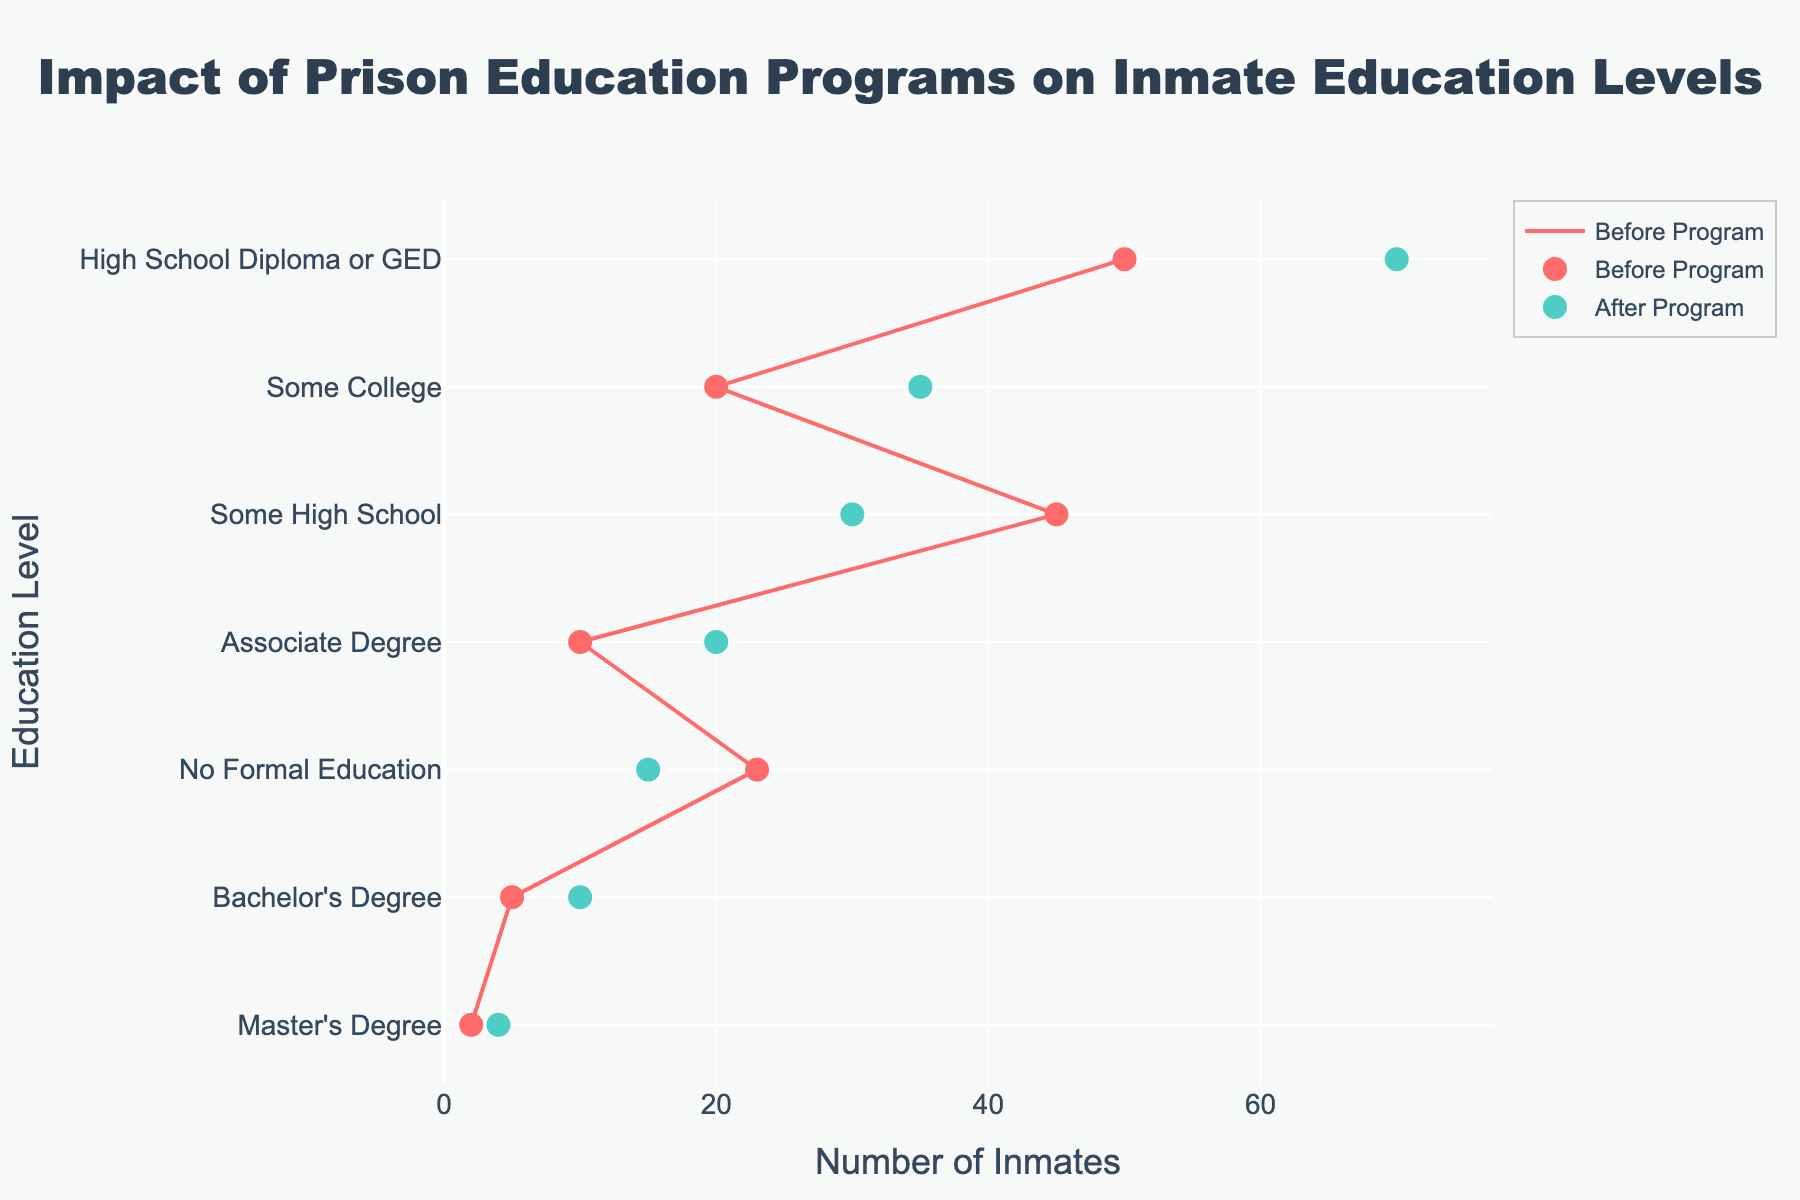How many education levels are represented in the plot? The y-axis lists each education level, so count the distinct education levels shown. There are 7 levels shown on the y-axis: No Formal Education, Some High School, High School Diploma or GED, Some College, Associate Degree, Bachelor's Degree, and Master's Degree.
Answer: 7 Which education level saw the greatest increase in the number of inmates after the program? To determine this, compare the difference between the numbers of inmates before and after the program for each education level. The greatest increase is from 50 to 70 for "High School Diploma or GED," which is an increase of 20 inmates.
Answer: High School Diploma or GED How many more inmates had a Bachelor's Degree after the program compared to before? Look at the data points for Bachelor's Degree before and after the program. The number increased from 5 to 10, so the difference is 10 - 5 = 5 inmates.
Answer: 5 What is the total number of inmates with at least some college education before the program? Sum the number of inmates for the categories of Some College, Associate Degree, Bachelor's Degree, and Master's Degree before the program. This is 20 + 10 + 5 + 2 = 37 inmates.
Answer: 37 Which education level had the highest number of inmates before the program? Look at the x-axis values for the "Before Program" markers and identify the highest one. This is for "High School Diploma or GED," with 50 inmates.
Answer: High School Diploma or GED How many inmates improved their education level to at least an Associate Degree after the program? Sum the number of inmates for the categories of Associate Degree, Bachelor's Degree, and Master's Degree after the program. This is 20 + 10 + 4 = 34 inmates.
Answer: 34 Compare the changes in inmate numbers for "Some High School" and "Some College" education levels. Which one saw a greater absolute change? Calculate the absolute difference for both education levels: Some High School (45 - 30 = 15), Some College (35 - 20 = 15). Both education levels saw the same absolute change of 15 inmates.
Answer: Both saw the same change What is the average number of inmates for those with "No Formal Education" and "Some High School" after the program? Find the sum and then the average. No Formal Education (15), Some High School (30). Sum is 15 + 30 = 45. The average is 45 / 2 = 22.5.
Answer: 22.5 What percentage of inmates had at least a High School Diploma or GED after the program? Sum the inmates for High School Diploma or GED, Some College, Associate Degree, Bachelor's Degree, and Master's Degree after the program: 70 + 35 + 20 + 10 + 4 = 139. The total number of inmates after the program is 15 + 30 + 70 + 35 + 20 + 10 + 4 = 184. The percentage is (139 / 184) * 100 ≈ 75.5%.
Answer: 75.5% 